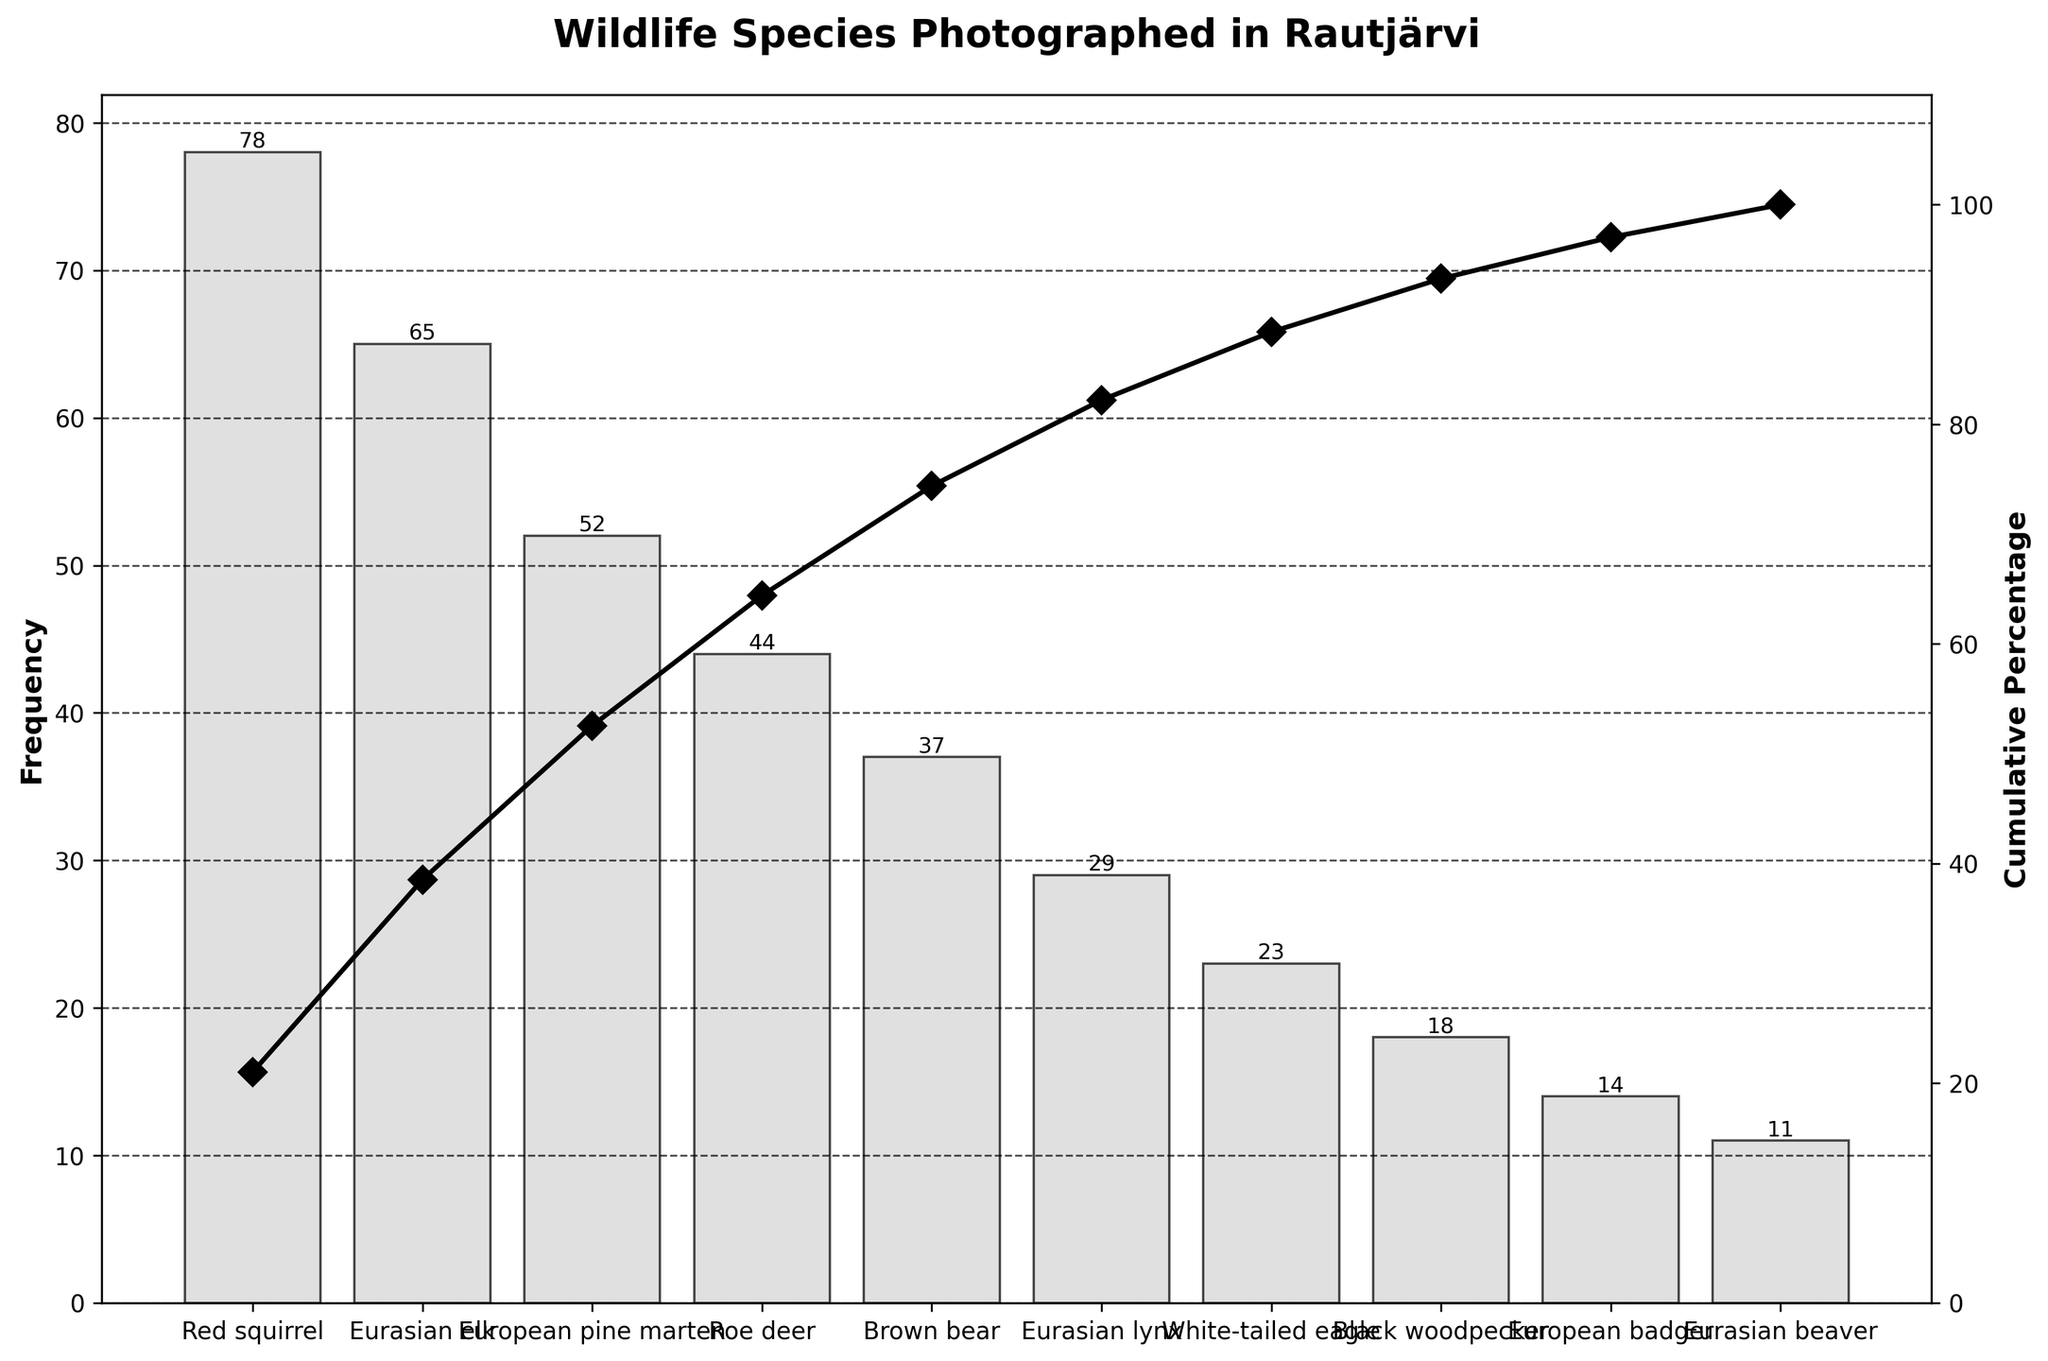What's the title of the chart? The title of the chart is prominently displayed at the top.
Answer: "Wildlife Species Photographed in Rautjärvi" How many different species are represented in the chart? The chart lists species along the x-axis, and you can count the number of distinct labels.
Answer: 10 Which species has the highest frequency of photographs? The species with the tallest bar in the chart has the highest frequency.
Answer: Red squirrel What is the cumulative percentage for the top three species? Sum the frequencies of the top three species, then divide by the total frequency and multiply by 100 to get the cumulative percentage. The top three species' frequencies are 78 (Red squirrel), 65 (Eurasian elk), and 52 (European pine marten), totaling 195. The total frequency is 371. So, (195/371)*100 is approximately 52.56%.
Answer: Approximately 52.56% How does the cumulative percentage for Brown bear compare to that for Roe deer? Find the cumulative percentage values for both Brown bear and Roe deer and compare them. Brown bear has a cumulative percentage lower than Roe deer since it is a part of the cumulative total up to its position.
Answer: Roe deer has a higher cumulative percentage than Brown bear What is the combined frequency of the bottom five species? Add the frequencies of the bottom five species: White-tailed eagle (23), Black woodpecker (18), European badger (14), Eurasian beaver (11).
Answer: 66 Which species has a frequency closest to the mean frequency of all the species? Calculate the mean frequency by dividing the total frequency by the number of species and find the species frequency closest to this mean. The mean frequency is 371/10 = 37.1, and Brown bear has a frequency of 37.
Answer: Brown bear Between Eurasian beaver and European badger, which species has a higher frequency of photographs? Compare the heights of the bars for Eurasian beaver and European badger.
Answer: European badger At what cumulative percentage does the Eurasian lynx appear? Locate the Eurasian lynx in the chart and check the corresponding cumulative percentage value.
Answer: About 71.15% What percentage of the total photographs are of Eurasian elk and Roe deer combined? Add the frequencies of Eurasian elk (65) and Roe deer (44), then divide by the total frequency and multiply by 100. The combined frequency is 65 + 44 = 109. So, (109/371)*100 is approximately 29.38%.
Answer: Approximately 29.38% 